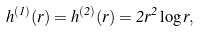Convert formula to latex. <formula><loc_0><loc_0><loc_500><loc_500>h ^ { ( 1 ) } ( r ) = h ^ { ( 2 ) } ( r ) = 2 r ^ { 2 } \log r ,</formula> 